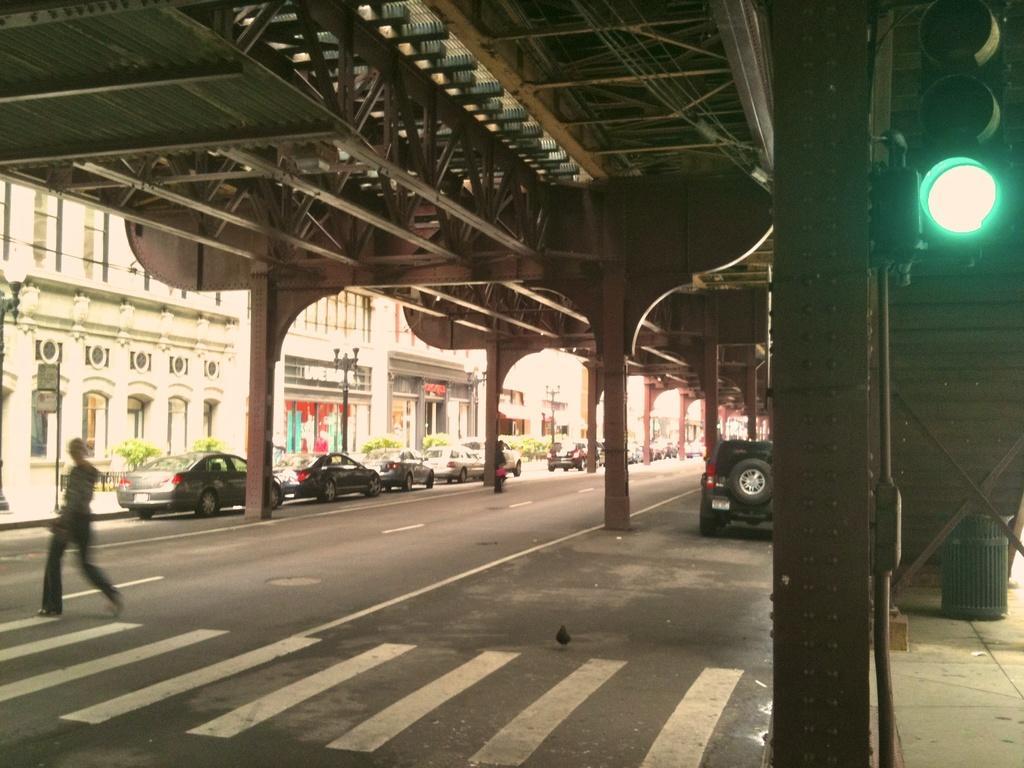Describe this image in one or two sentences. In this image, I can see the cars on the road. These are the pillars. It looks like a metal beams. On the left side of the image, I can see a person walking. At the top right side of the image, I can see a traffic light and a dustbin. On the right side of the image, these are the buildings and bushes. 